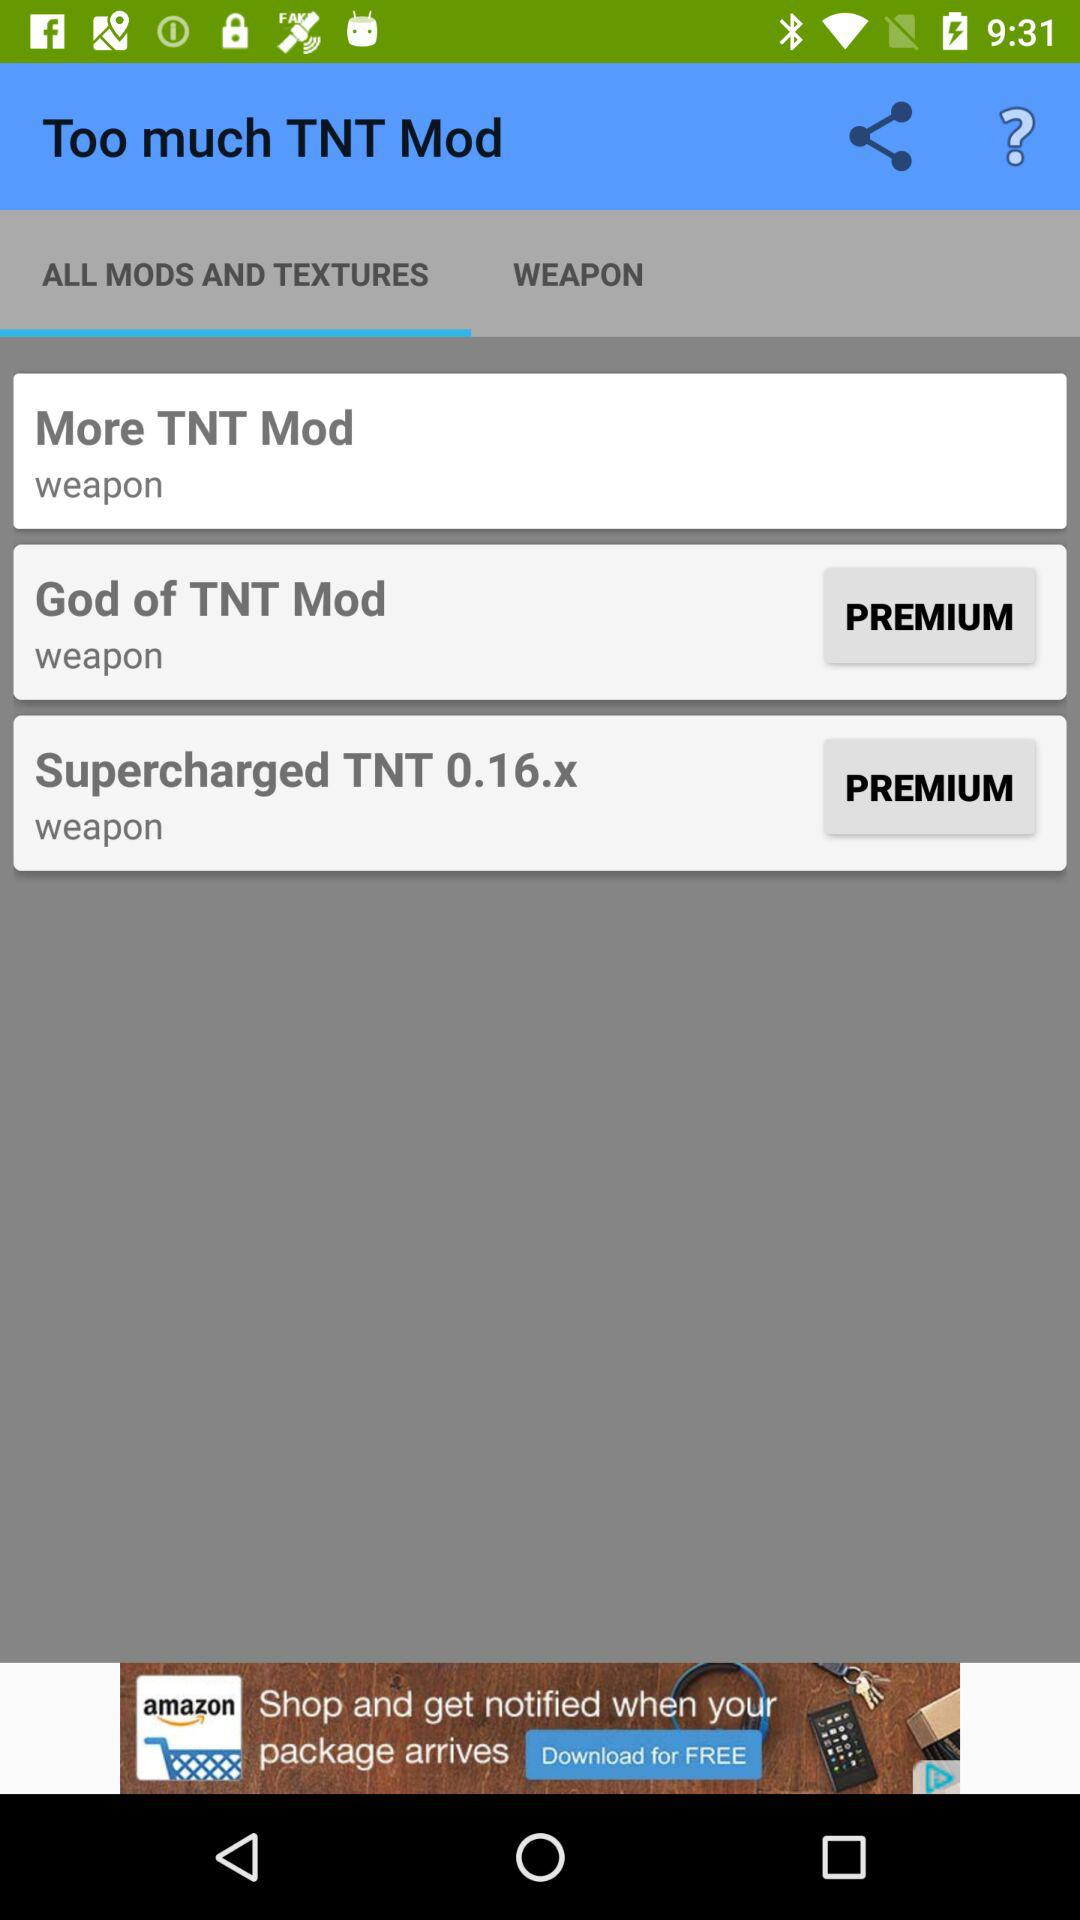How many weapon mods are there?
Answer the question using a single word or phrase. 3 